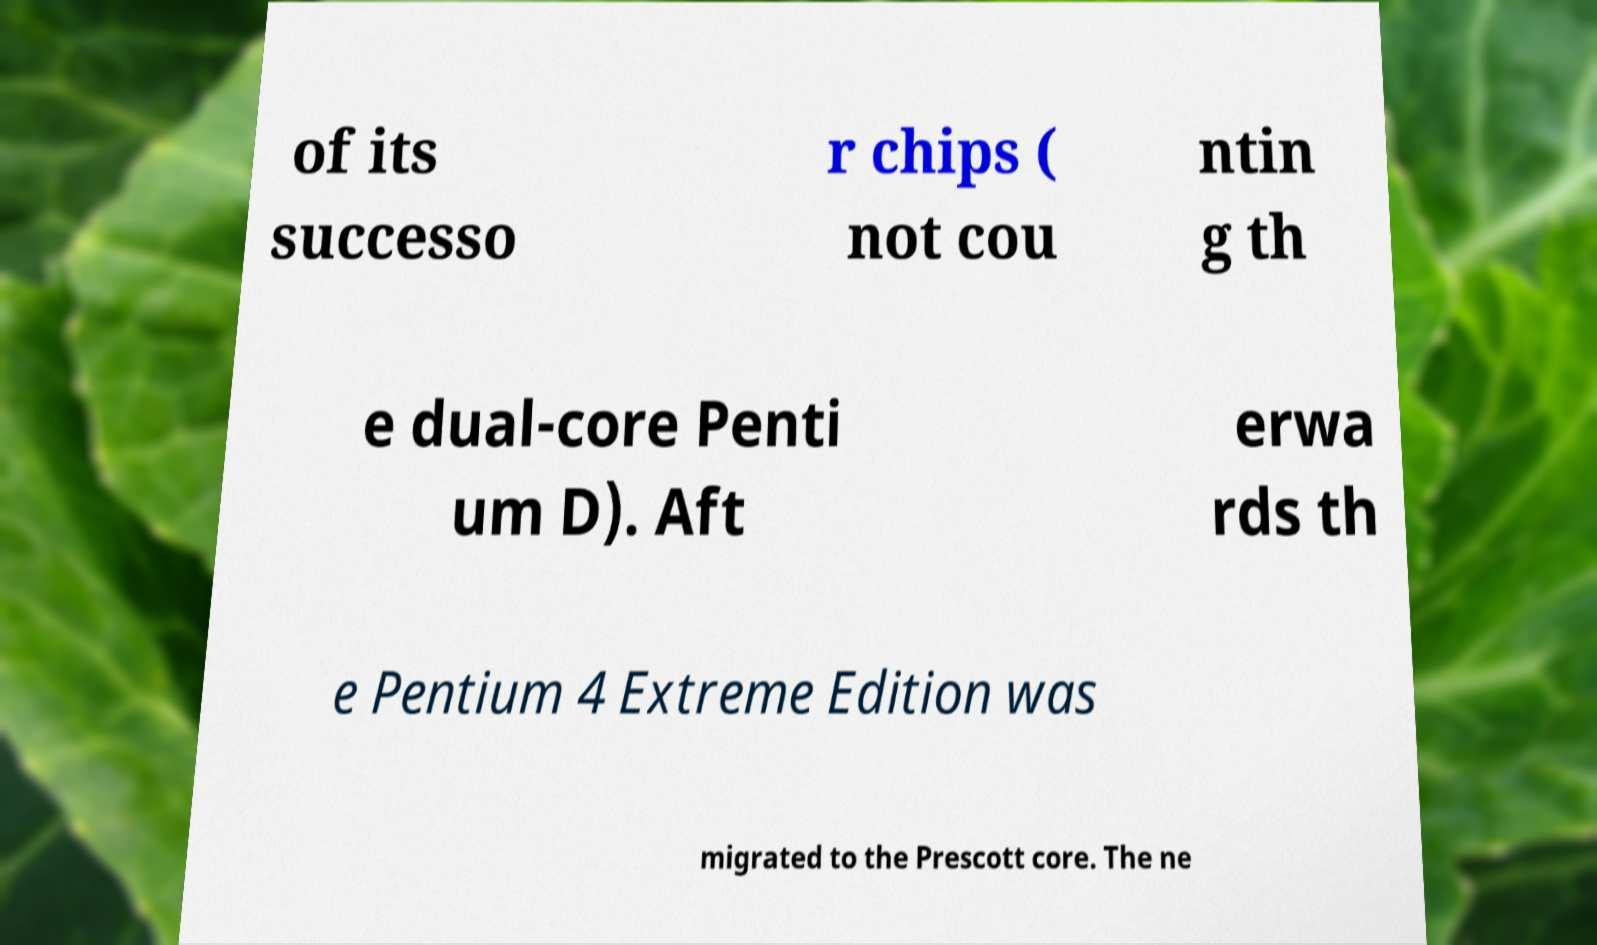There's text embedded in this image that I need extracted. Can you transcribe it verbatim? of its successo r chips ( not cou ntin g th e dual-core Penti um D). Aft erwa rds th e Pentium 4 Extreme Edition was migrated to the Prescott core. The ne 